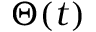<formula> <loc_0><loc_0><loc_500><loc_500>\Theta ( t )</formula> 